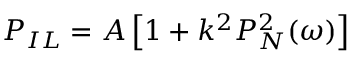<formula> <loc_0><loc_0><loc_500><loc_500>P _ { I L } = A \left [ 1 + k ^ { 2 } P _ { N } ^ { 2 } ( \omega ) \right ]</formula> 